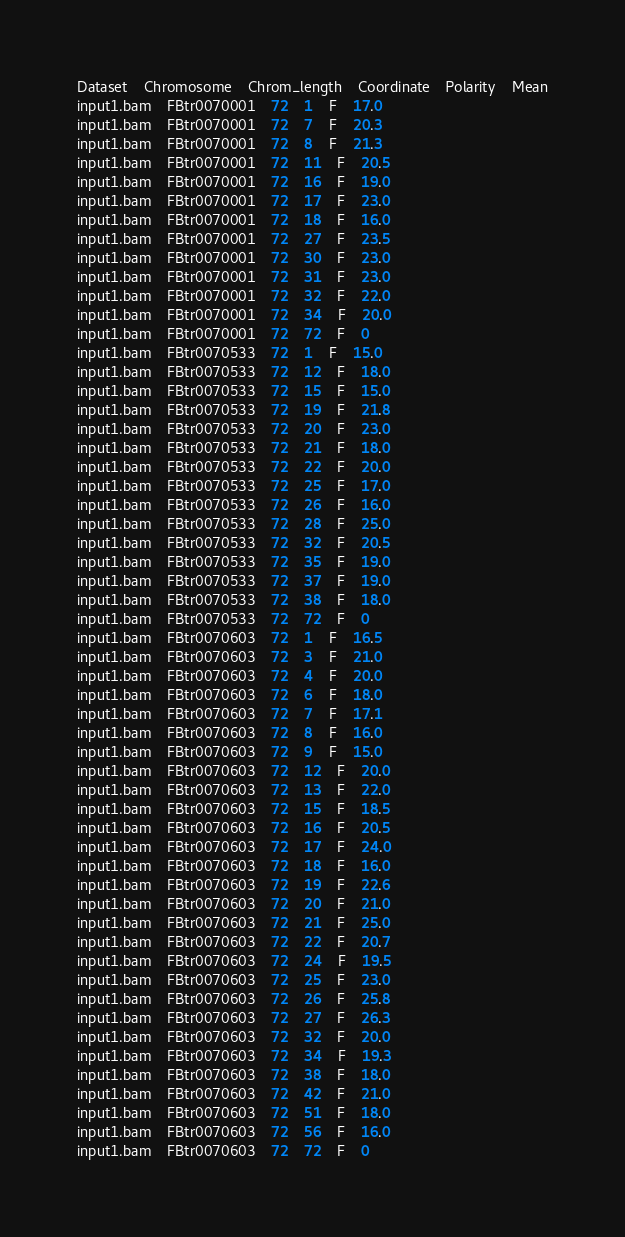<code> <loc_0><loc_0><loc_500><loc_500><_SQL_>Dataset	Chromosome	Chrom_length	Coordinate	Polarity	Mean
input1.bam	FBtr0070001	72	1	F	17.0
input1.bam	FBtr0070001	72	7	F	20.3
input1.bam	FBtr0070001	72	8	F	21.3
input1.bam	FBtr0070001	72	11	F	20.5
input1.bam	FBtr0070001	72	16	F	19.0
input1.bam	FBtr0070001	72	17	F	23.0
input1.bam	FBtr0070001	72	18	F	16.0
input1.bam	FBtr0070001	72	27	F	23.5
input1.bam	FBtr0070001	72	30	F	23.0
input1.bam	FBtr0070001	72	31	F	23.0
input1.bam	FBtr0070001	72	32	F	22.0
input1.bam	FBtr0070001	72	34	F	20.0
input1.bam	FBtr0070001	72	72	F	0
input1.bam	FBtr0070533	72	1	F	15.0
input1.bam	FBtr0070533	72	12	F	18.0
input1.bam	FBtr0070533	72	15	F	15.0
input1.bam	FBtr0070533	72	19	F	21.8
input1.bam	FBtr0070533	72	20	F	23.0
input1.bam	FBtr0070533	72	21	F	18.0
input1.bam	FBtr0070533	72	22	F	20.0
input1.bam	FBtr0070533	72	25	F	17.0
input1.bam	FBtr0070533	72	26	F	16.0
input1.bam	FBtr0070533	72	28	F	25.0
input1.bam	FBtr0070533	72	32	F	20.5
input1.bam	FBtr0070533	72	35	F	19.0
input1.bam	FBtr0070533	72	37	F	19.0
input1.bam	FBtr0070533	72	38	F	18.0
input1.bam	FBtr0070533	72	72	F	0
input1.bam	FBtr0070603	72	1	F	16.5
input1.bam	FBtr0070603	72	3	F	21.0
input1.bam	FBtr0070603	72	4	F	20.0
input1.bam	FBtr0070603	72	6	F	18.0
input1.bam	FBtr0070603	72	7	F	17.1
input1.bam	FBtr0070603	72	8	F	16.0
input1.bam	FBtr0070603	72	9	F	15.0
input1.bam	FBtr0070603	72	12	F	20.0
input1.bam	FBtr0070603	72	13	F	22.0
input1.bam	FBtr0070603	72	15	F	18.5
input1.bam	FBtr0070603	72	16	F	20.5
input1.bam	FBtr0070603	72	17	F	24.0
input1.bam	FBtr0070603	72	18	F	16.0
input1.bam	FBtr0070603	72	19	F	22.6
input1.bam	FBtr0070603	72	20	F	21.0
input1.bam	FBtr0070603	72	21	F	25.0
input1.bam	FBtr0070603	72	22	F	20.7
input1.bam	FBtr0070603	72	24	F	19.5
input1.bam	FBtr0070603	72	25	F	23.0
input1.bam	FBtr0070603	72	26	F	25.8
input1.bam	FBtr0070603	72	27	F	26.3
input1.bam	FBtr0070603	72	32	F	20.0
input1.bam	FBtr0070603	72	34	F	19.3
input1.bam	FBtr0070603	72	38	F	18.0
input1.bam	FBtr0070603	72	42	F	21.0
input1.bam	FBtr0070603	72	51	F	18.0
input1.bam	FBtr0070603	72	56	F	16.0
input1.bam	FBtr0070603	72	72	F	0</code> 